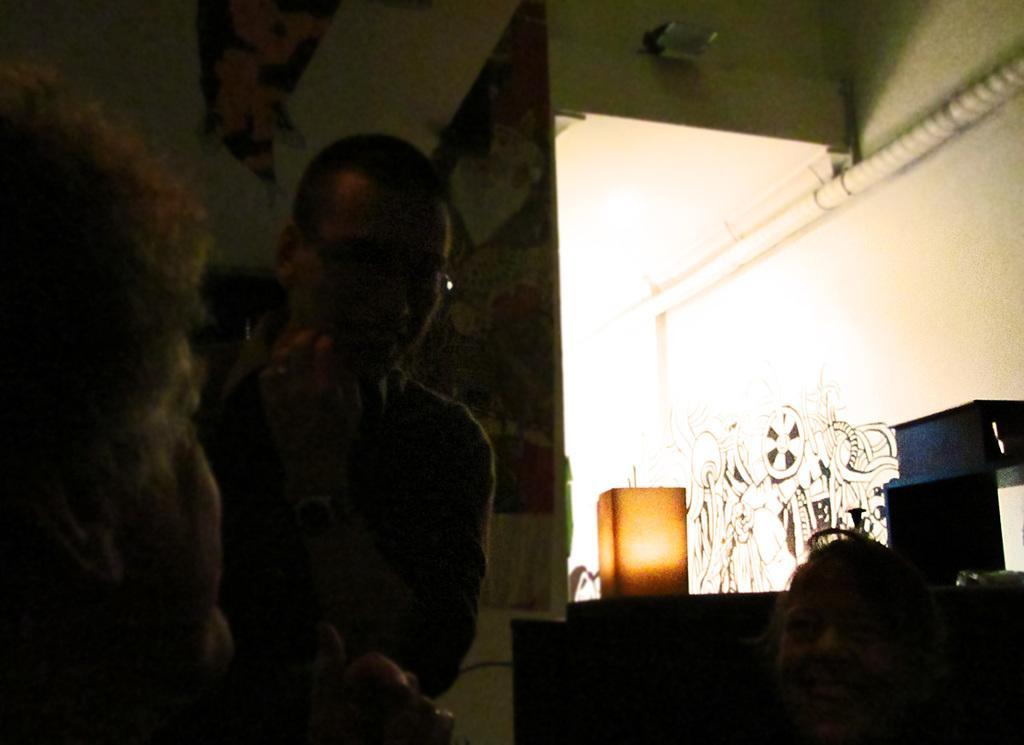Please provide a concise description of this image. In this picture I can see three persons, there is light and some other objects, and in the background there is a board and a painting on the walls. 